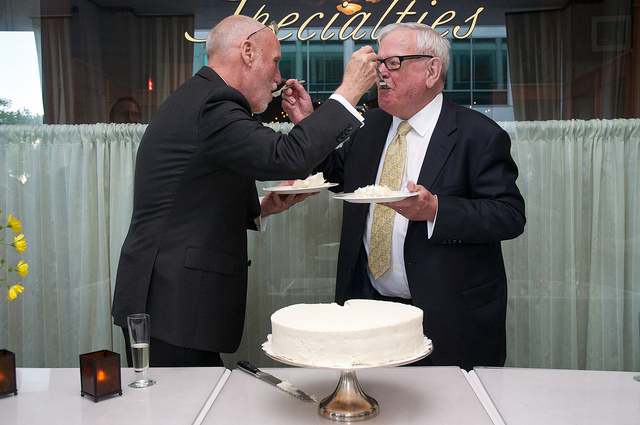Identify and read out the text in this image. specialties 